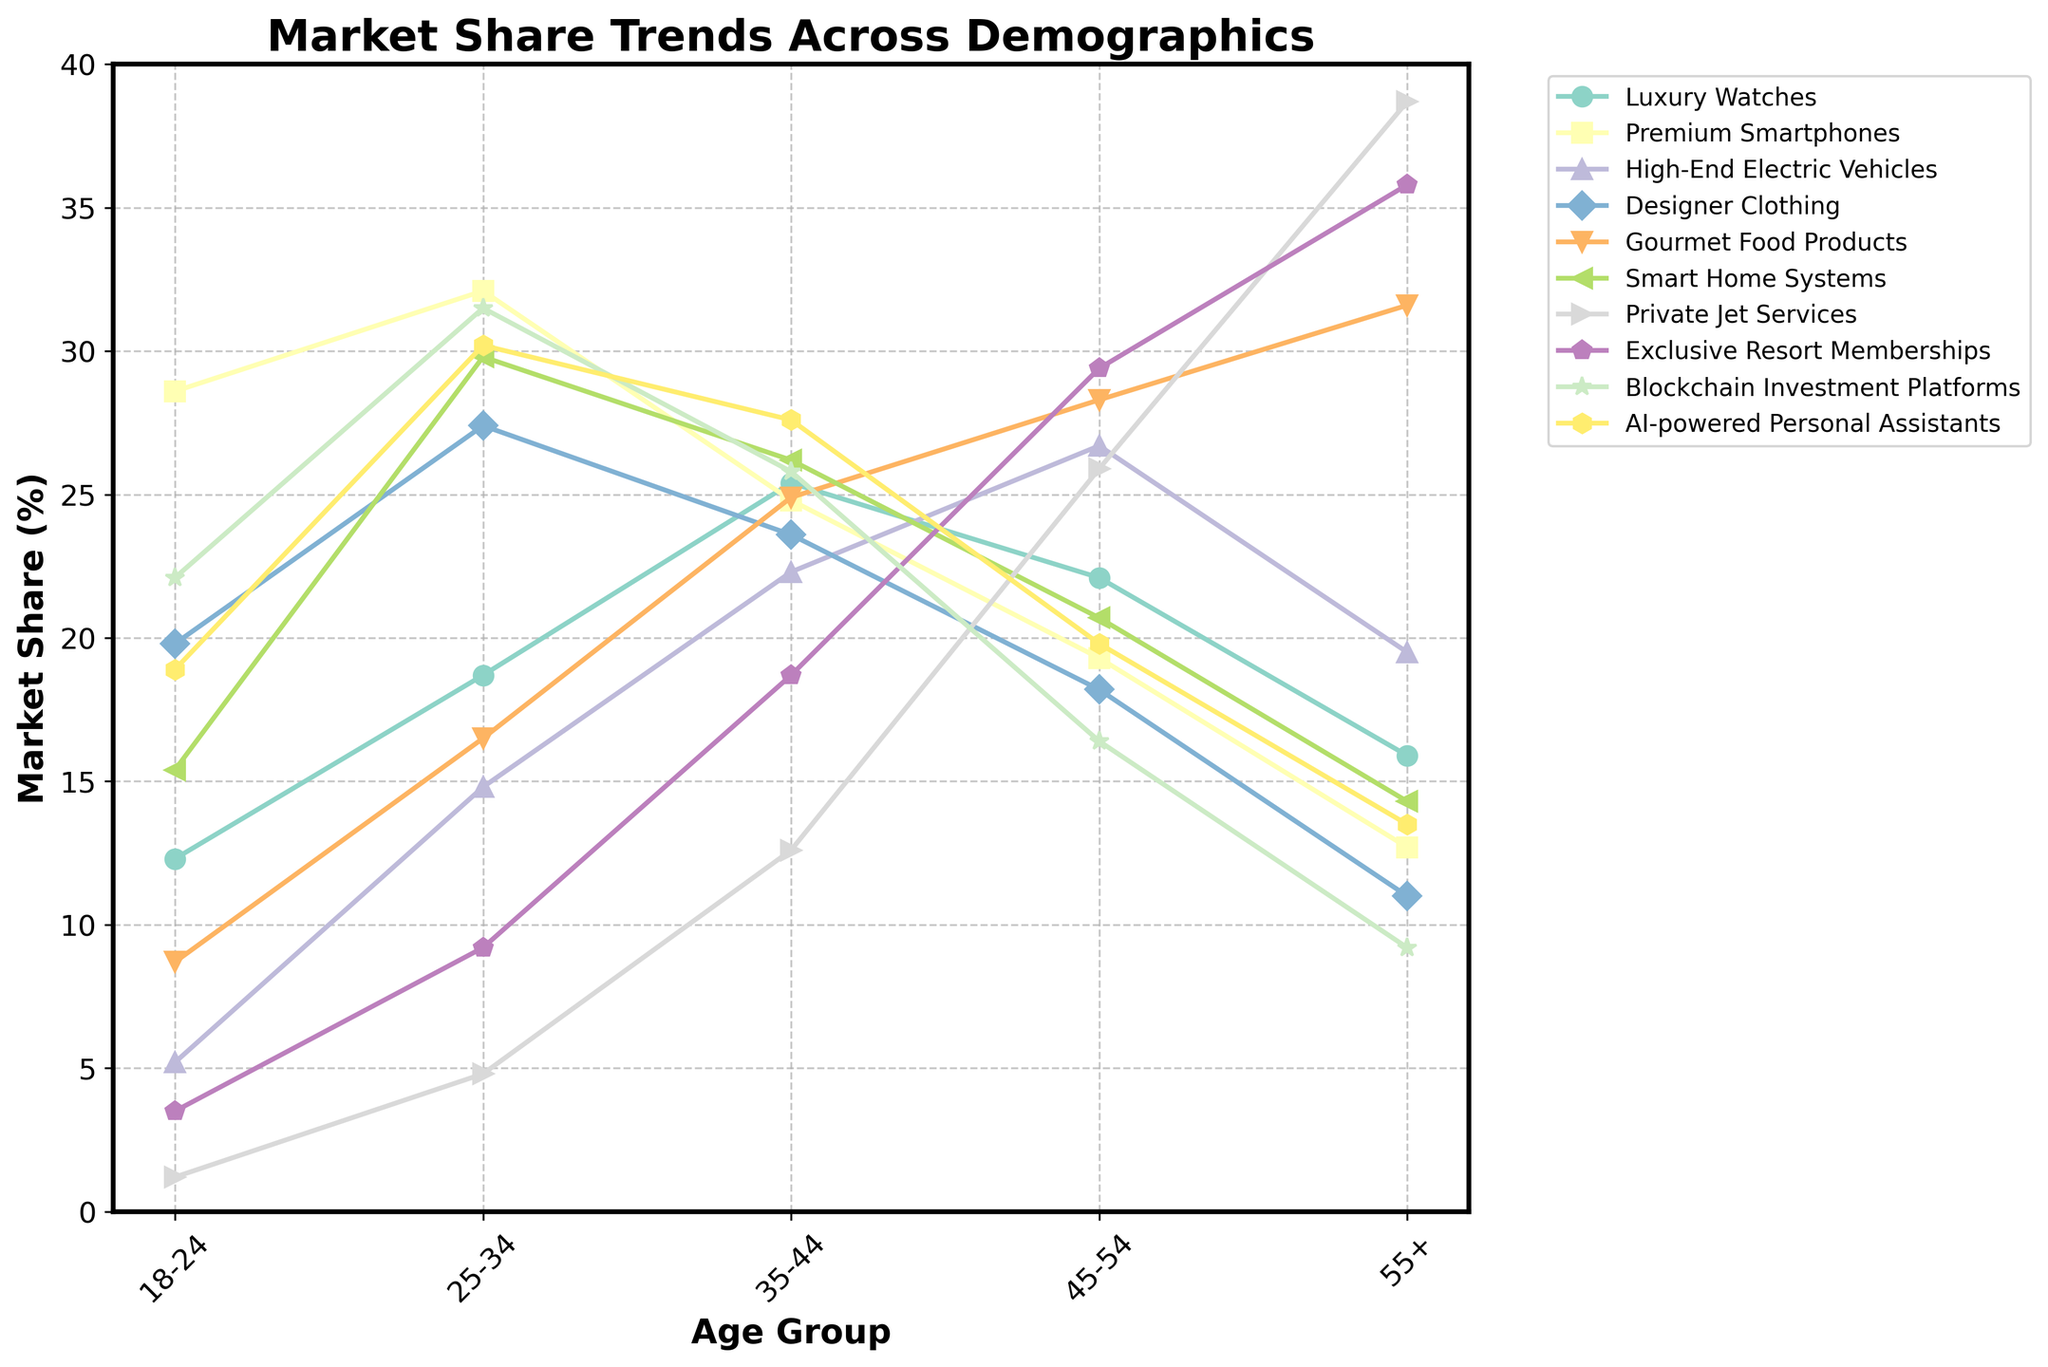What's the most preferred product among the 25-34 age group? Among the 25-34 age group, the product with the highest market share is Premium Smartphones, as it has the highest value in this age group at 32.1%.
Answer: Premium Smartphones Which age group has the highest market share for Private Jet Services? The age group with the highest market share for Private Jet Services is the 55+ age group, as it shows the highest value at 38.7%.
Answer: 55+ What's the difference in market share between AI-powered Personal Assistants and Blockchain Investment Platforms for the 35-44 age group? For the 35-44 age group, AI-powered Personal Assistants have a market share of 27.6%, while Blockchain Investment Platforms have a market share of 25.8%. The difference is 27.6% - 25.8% = 1.8%.
Answer: 1.8% What's the average market share for Gourmet Food Products across all age groups? The market share for Gourmet Food Products is 8.7% for 18-24, 16.5% for 25-34, 24.9% for 35-44, 28.3% for 45-54, and 31.6% for 55+. Adding these values gives 8.7 + 16.5 + 24.9 + 28.3 + 31.6 = 110. Averaging them gives 110 / 5 = 22%.
Answer: 22% Which product has the steepest increase in market share from the 18-24 age group to the 55+ age group? To find the steepest increase, we subtract the market share at the 18-24 age group from the market share at the 55+ age group for each product. Private Jet Services increases from 1.2% to 38.7%, a difference of 38.7% - 1.2% = 37.5%, which is the largest increase among the products listed.
Answer: Private Jet Services Among the 45-54 age group, what are the second and third most popular products? For the 45-54 age group, Gourmet Food Products have the highest market share at 28.3%, and Exclusive Resort Memberships have the second highest at 29.4%. The next highest are Luxury Watches at 22.1% and High-End Electric Vehicles at 26.7%. So the second most popular product is High-End Electric Vehicles and the third most popular is Luxury Watches.
Answer: High-End Electric Vehicles, Luxury Watches Is the pattern of market share for Designer Clothing across age groups increasing, decreasing, or mixed? By examining the market share values for Designer Clothing across age groups (18-24: 19.8%, 25-34: 27.4%, 35-44: 23.6%, 45-54: 18.2%, 55+: 11.0%), we can see that it initially increases from 18-24 to 25-34, then decreases consistently from 25-34 to 55+. Thus, the pattern is mixed.
Answer: Mixed What is the total market share percentage for all products in the 55+ age group? Adding up market share percentages for all products in the 55+ age group: Luxury Watches (15.9%), Premium Smartphones (12.7%), High-End Electric Vehicles (19.5%), Designer Clothing (11.0%), Gourmet Food Products (31.6%), Smart Home Systems (14.3%), Private Jet Services (38.7%), Exclusive Resort Memberships (35.8%), Blockchain Investment Platforms (9.2%), AI-powered Personal Assistants (13.5%), we get 15.9 + 12.7 + 19.5 + 11.0 + 31.6 + 14.3 + 38.7 + 35.8 + 9.2 + 13.5 = 202.2%.
Answer: 202.2% 